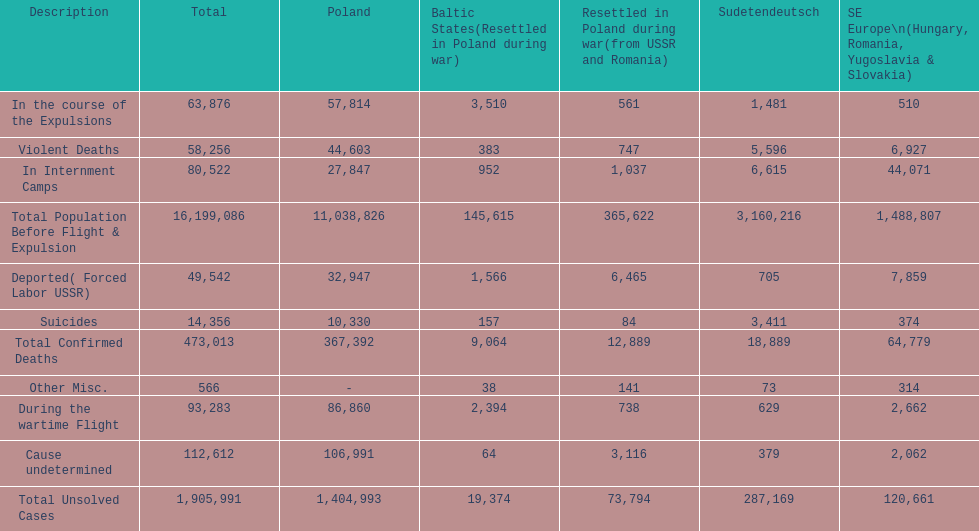What was the cause of the most deaths? Cause undetermined. 